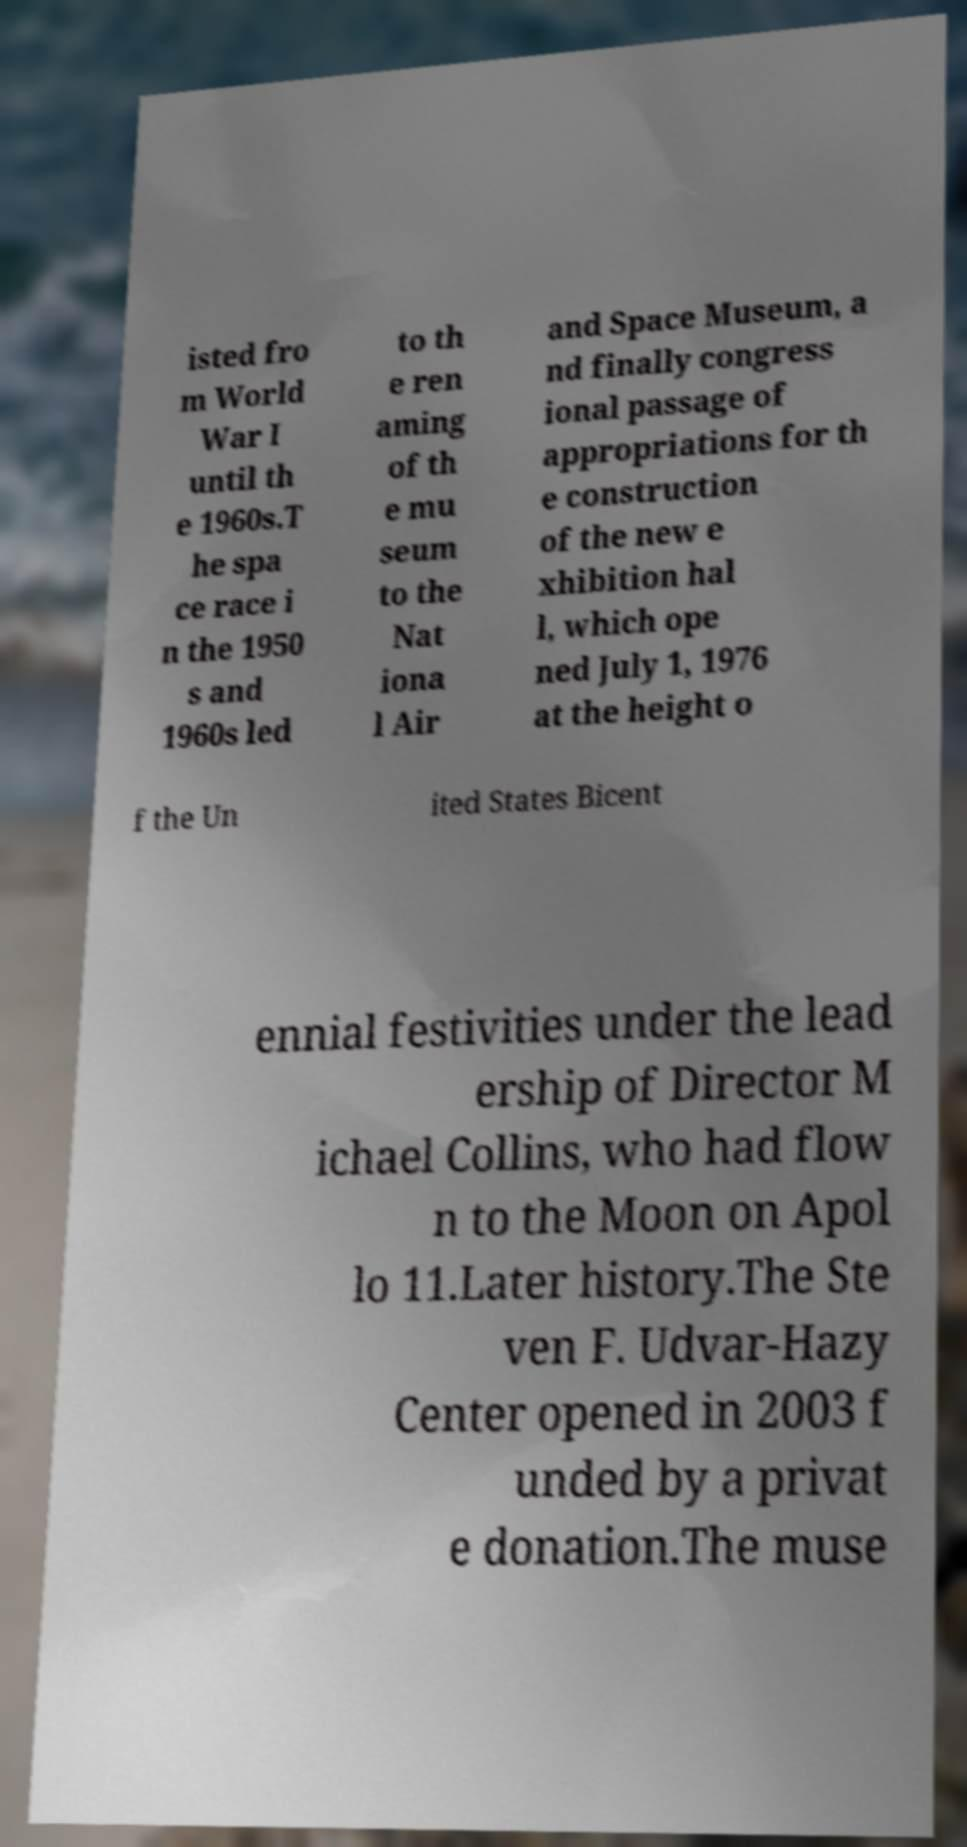Could you extract and type out the text from this image? isted fro m World War I until th e 1960s.T he spa ce race i n the 1950 s and 1960s led to th e ren aming of th e mu seum to the Nat iona l Air and Space Museum, a nd finally congress ional passage of appropriations for th e construction of the new e xhibition hal l, which ope ned July 1, 1976 at the height o f the Un ited States Bicent ennial festivities under the lead ership of Director M ichael Collins, who had flow n to the Moon on Apol lo 11.Later history.The Ste ven F. Udvar-Hazy Center opened in 2003 f unded by a privat e donation.The muse 